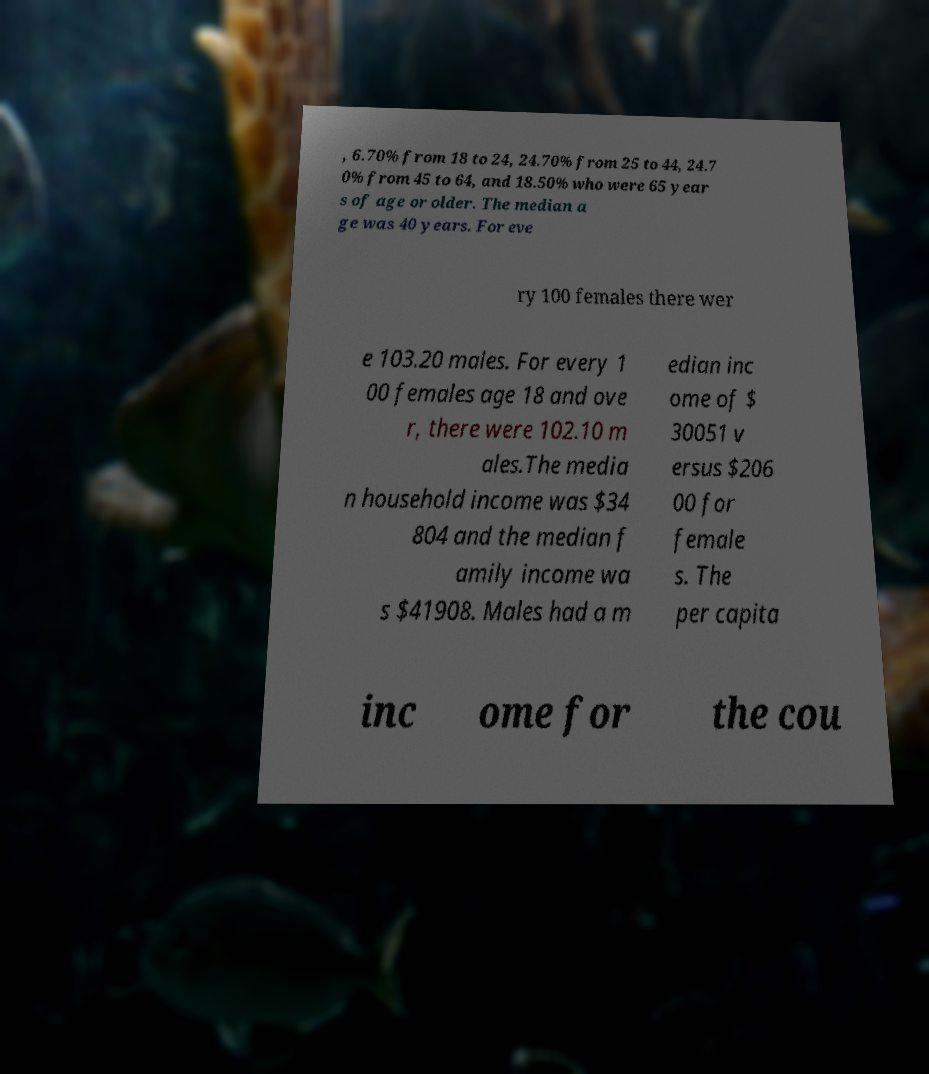There's text embedded in this image that I need extracted. Can you transcribe it verbatim? , 6.70% from 18 to 24, 24.70% from 25 to 44, 24.7 0% from 45 to 64, and 18.50% who were 65 year s of age or older. The median a ge was 40 years. For eve ry 100 females there wer e 103.20 males. For every 1 00 females age 18 and ove r, there were 102.10 m ales.The media n household income was $34 804 and the median f amily income wa s $41908. Males had a m edian inc ome of $ 30051 v ersus $206 00 for female s. The per capita inc ome for the cou 